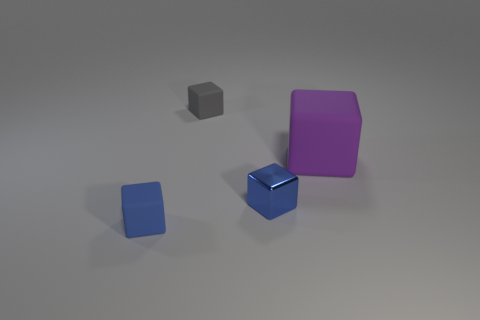Is there a small cube that has the same material as the small gray thing?
Give a very brief answer. Yes. How many things are behind the large purple rubber thing and in front of the metal cube?
Provide a short and direct response. 0. Is the number of small blue matte things on the left side of the small gray rubber object less than the number of blue blocks left of the tiny metal thing?
Your response must be concise. No. Does the purple object have the same shape as the metal thing?
Your response must be concise. Yes. How many other objects are the same size as the gray block?
Offer a very short reply. 2. How many objects are matte things that are in front of the tiny gray block or things that are right of the tiny gray matte object?
Make the answer very short. 3. How many other matte objects are the same shape as the large thing?
Ensure brevity in your answer.  2. What is the material of the tiny thing that is both in front of the tiny gray cube and to the right of the blue matte block?
Make the answer very short. Metal. There is a tiny metallic block; what number of big purple blocks are on the left side of it?
Your answer should be very brief. 0. How many blue metal blocks are there?
Offer a terse response. 1. 